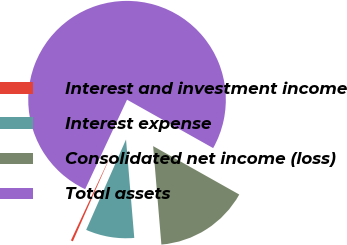Convert chart. <chart><loc_0><loc_0><loc_500><loc_500><pie_chart><fcel>Interest and investment income<fcel>Interest expense<fcel>Consolidated net income (loss)<fcel>Total assets<nl><fcel>0.35%<fcel>7.94%<fcel>15.52%<fcel>76.19%<nl></chart> 